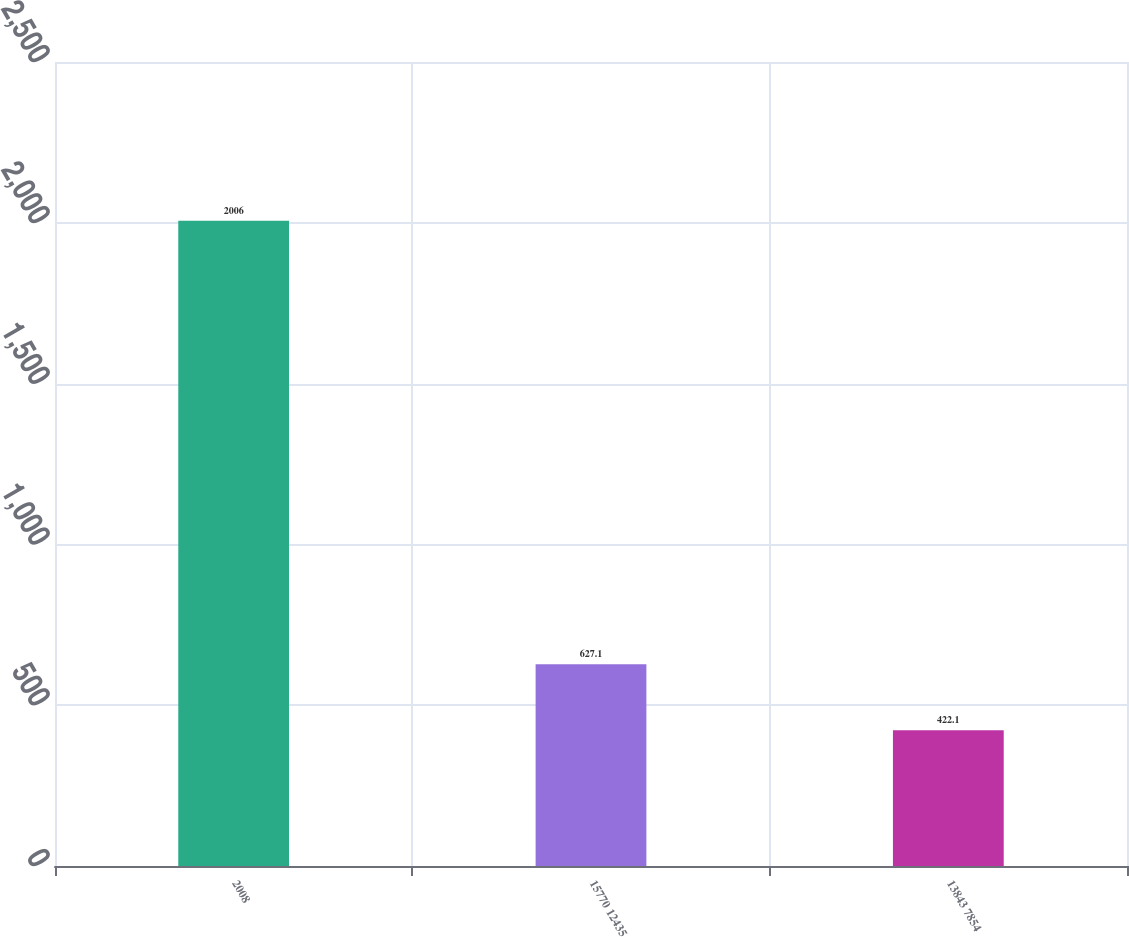Convert chart to OTSL. <chart><loc_0><loc_0><loc_500><loc_500><bar_chart><fcel>2008<fcel>15770 12435<fcel>13843 7854<nl><fcel>2006<fcel>627.1<fcel>422.1<nl></chart> 